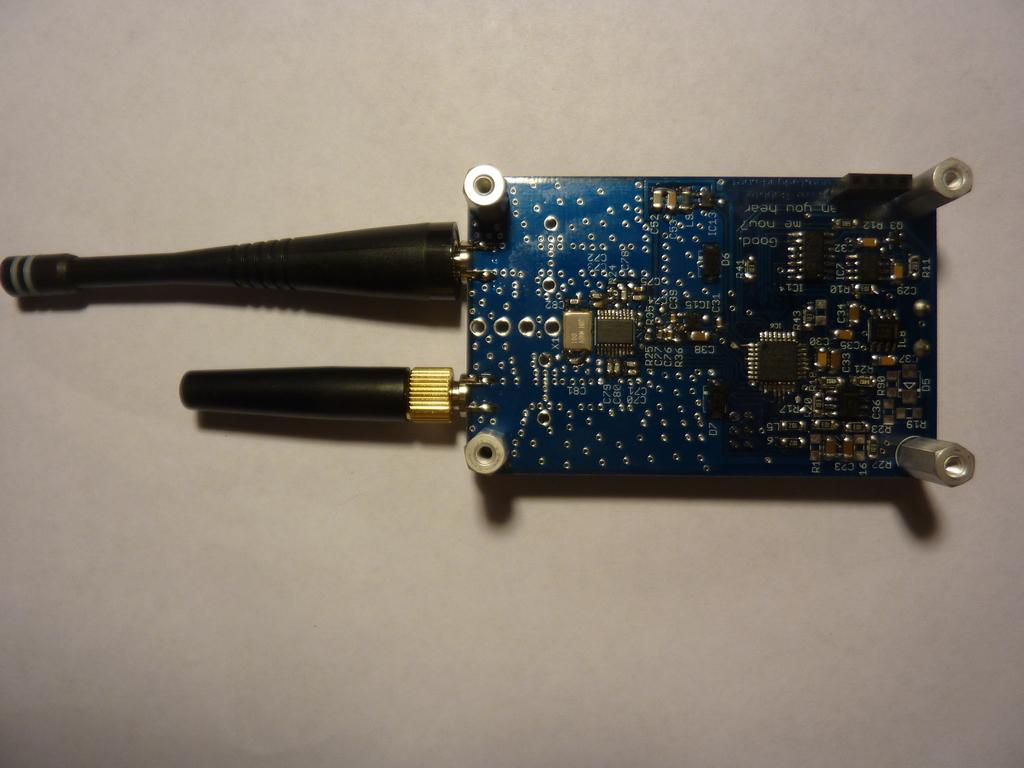Can you describe the image in more detail so that we can create a conversation based on it? Unfortunately, I do not have enough information about the image to provide a detailed description. How many yaks are present in the image? There is no information about yaks or any other animals in the image, as there are no specific facts provided. 